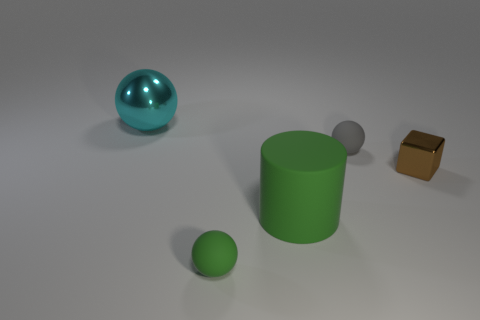Can you tell me the colors of all the objects starting from the left? Certainly! Starting from the left, the large sphere is teal, the cylinder is green, the tiny sphere is silver, and the small cube is golden brown. 